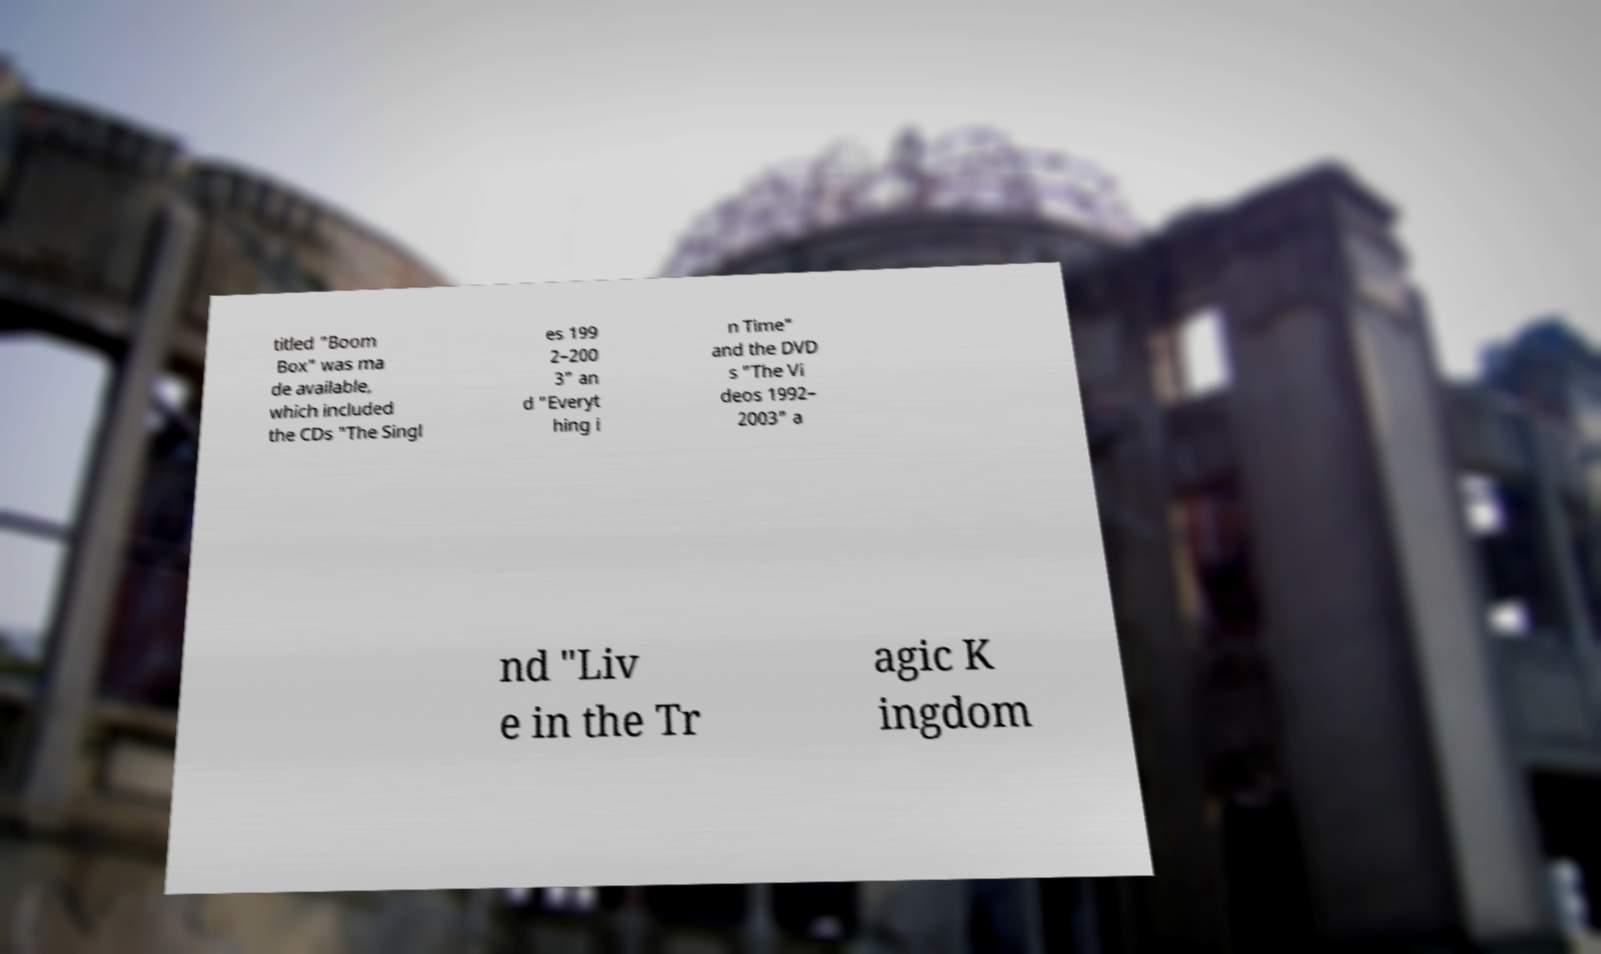Can you accurately transcribe the text from the provided image for me? titled "Boom Box" was ma de available, which included the CDs "The Singl es 199 2–200 3" an d "Everyt hing i n Time" and the DVD s "The Vi deos 1992– 2003" a nd "Liv e in the Tr agic K ingdom 